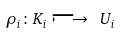Convert formula to latex. <formula><loc_0><loc_0><loc_500><loc_500>\rho _ { i } \colon K _ { i } \longmapsto \ U _ { i }</formula> 